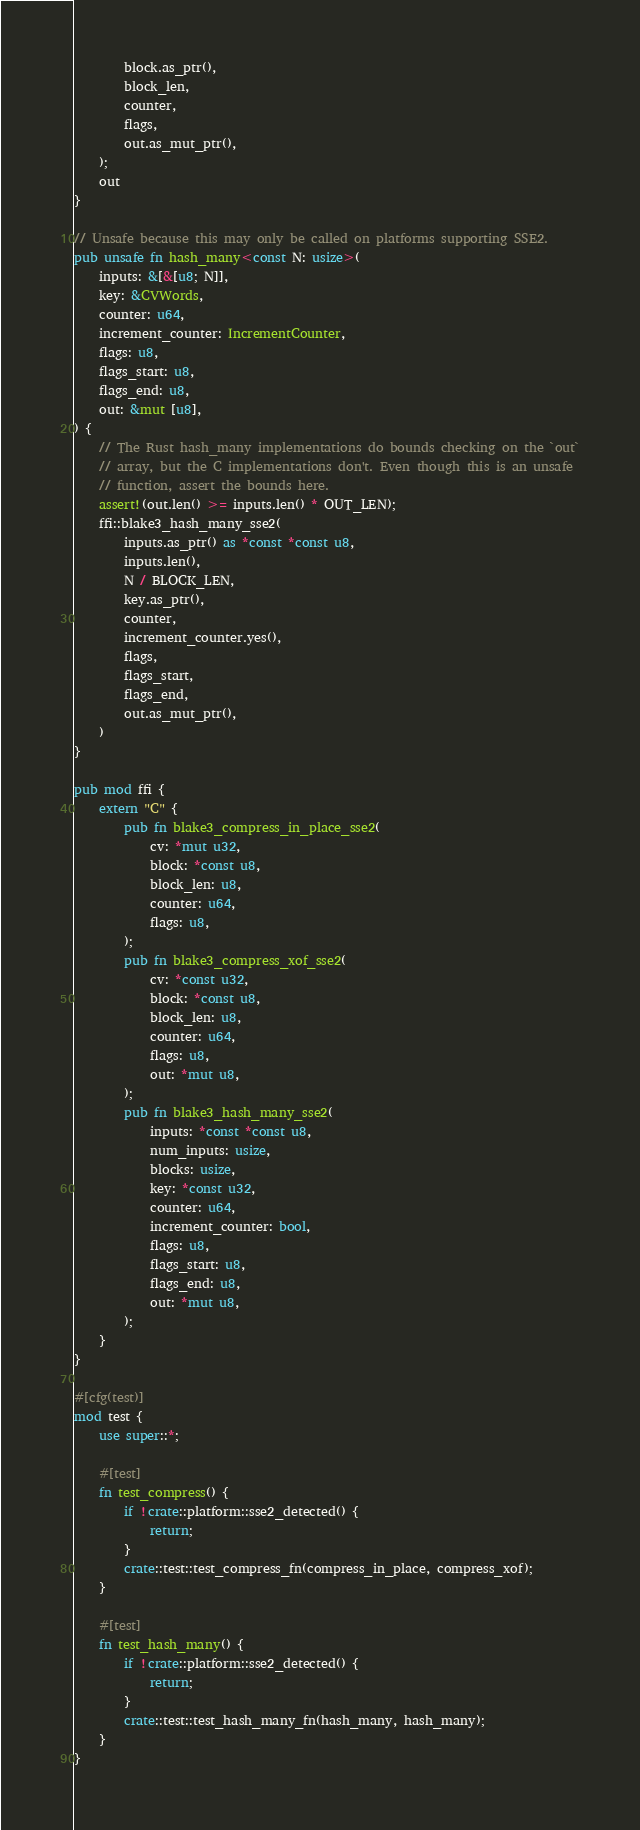<code> <loc_0><loc_0><loc_500><loc_500><_Rust_>        block.as_ptr(),
        block_len,
        counter,
        flags,
        out.as_mut_ptr(),
    );
    out
}

// Unsafe because this may only be called on platforms supporting SSE2.
pub unsafe fn hash_many<const N: usize>(
    inputs: &[&[u8; N]],
    key: &CVWords,
    counter: u64,
    increment_counter: IncrementCounter,
    flags: u8,
    flags_start: u8,
    flags_end: u8,
    out: &mut [u8],
) {
    // The Rust hash_many implementations do bounds checking on the `out`
    // array, but the C implementations don't. Even though this is an unsafe
    // function, assert the bounds here.
    assert!(out.len() >= inputs.len() * OUT_LEN);
    ffi::blake3_hash_many_sse2(
        inputs.as_ptr() as *const *const u8,
        inputs.len(),
        N / BLOCK_LEN,
        key.as_ptr(),
        counter,
        increment_counter.yes(),
        flags,
        flags_start,
        flags_end,
        out.as_mut_ptr(),
    )
}

pub mod ffi {
    extern "C" {
        pub fn blake3_compress_in_place_sse2(
            cv: *mut u32,
            block: *const u8,
            block_len: u8,
            counter: u64,
            flags: u8,
        );
        pub fn blake3_compress_xof_sse2(
            cv: *const u32,
            block: *const u8,
            block_len: u8,
            counter: u64,
            flags: u8,
            out: *mut u8,
        );
        pub fn blake3_hash_many_sse2(
            inputs: *const *const u8,
            num_inputs: usize,
            blocks: usize,
            key: *const u32,
            counter: u64,
            increment_counter: bool,
            flags: u8,
            flags_start: u8,
            flags_end: u8,
            out: *mut u8,
        );
    }
}

#[cfg(test)]
mod test {
    use super::*;

    #[test]
    fn test_compress() {
        if !crate::platform::sse2_detected() {
            return;
        }
        crate::test::test_compress_fn(compress_in_place, compress_xof);
    }

    #[test]
    fn test_hash_many() {
        if !crate::platform::sse2_detected() {
            return;
        }
        crate::test::test_hash_many_fn(hash_many, hash_many);
    }
}
</code> 